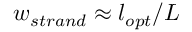Convert formula to latex. <formula><loc_0><loc_0><loc_500><loc_500>w _ { s t r a n d } \approx l _ { o p t } / L</formula> 